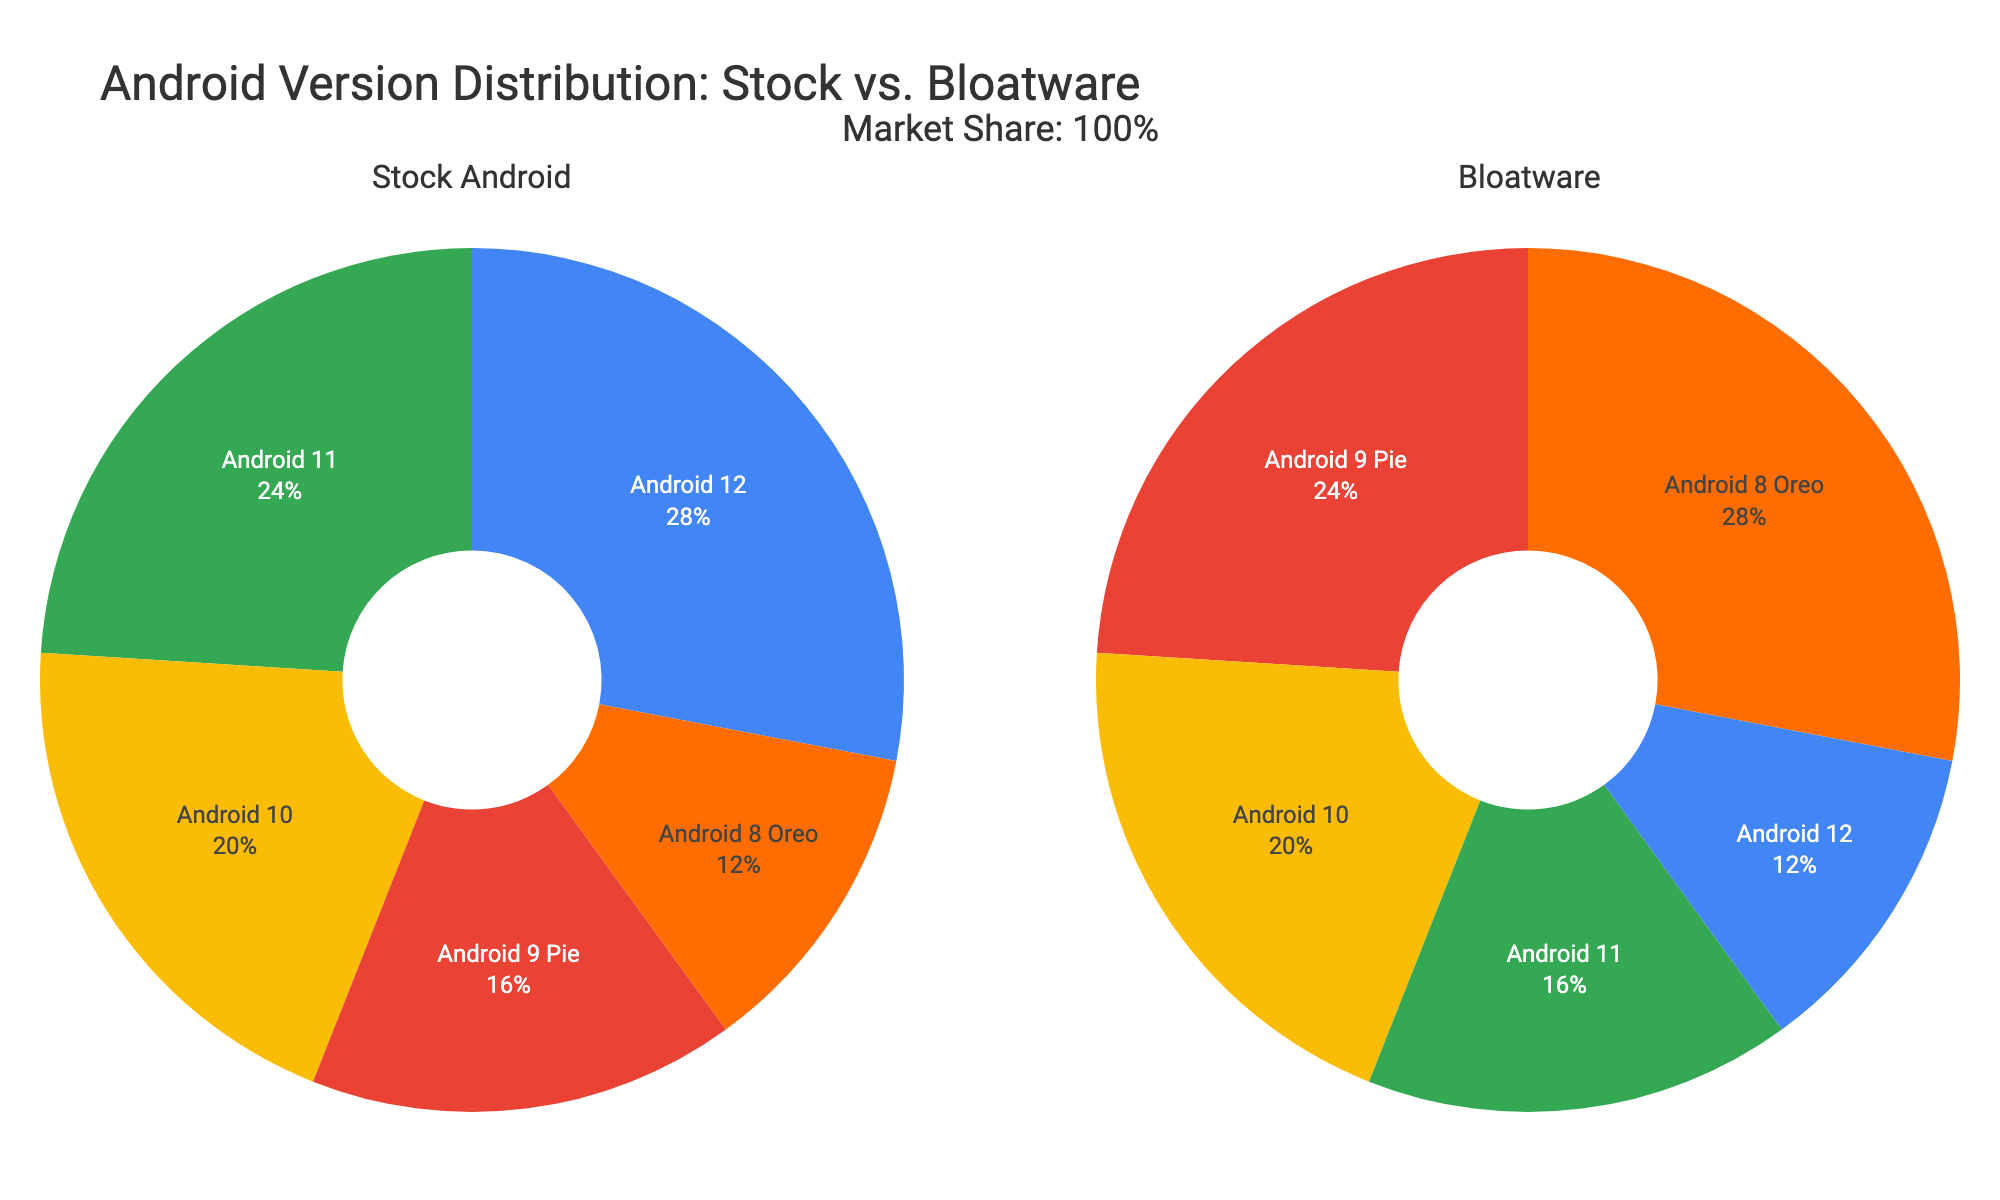What is the title of the figure? The title of the figure is located at the top and provides a summary of the data being visualized. By looking at the top of the figure, we can see the title "Android Version Distribution: Stock vs. Bloatware".
Answer: Android Version Distribution: Stock vs. Bloatware Which Android version has the highest percentage in stock Android? Each section of the stock Android pie chart is labeled with an Android version and its respective percentage. By examining these labels, we see that Android 12 has the highest percentage in stock Android.
Answer: Android 12 What is the total percentage of market share in the figure? The annotations below the subtitle mentioned, "Market Share: 100%", indicating that the total market share covered by all Android versions is 100%.
Answer: 100% Which Android version has a higher percentage of bloatware compared to stock Android? By comparing the percentages of each Android version in the "Stock Android" and "Bloatware" pie charts, we can see that Android 8 Oreo has a higher percentage in bloatware (70%) than in stock Android (30%).
Answer: Android 8 Oreo How many Android versions are depicted in the pie charts? By counting the distinct labels in each pie chart, we see that there are five Android versions: Android 12, Android 11, Android 10, Android 9 Pie, and Android 8 Oreo.
Answer: 5 Which Android version has the closest proportion between stock Android and bloatware? By observing the proportions of stock Android and bloatware for each version, Android 10 has an equal percentage of 50% for both stock Android and bloatware.
Answer: Android 10 What percentage of Android 11 users prefer stock Android? The percentage of stock Android users for each version is shown in the "Stock Android" pie chart. For Android 11, the percentage is 60%.
Answer: 60% What is the combined percentage of Android 11 and Android 12 users who prefer stock Android? Summing the percentages of stock Android for Android 11 (60%) and Android 12 (70%) yields 130%.
Answer: 130% Which chart displays the breakdown of users who have bloatware on their smartphones? The left chart is for stock Android, and the right chart is for bloatware, as indicated by the titles above each chart.
Answer: The right chart How much higher is the percentage of bloatware users for Android 9 Pie compared to the percentage of stock Android users for the same version? The respective percentages for Android 9 Pie are 40% for stock Android and 60% for bloatware. The difference is 60% - 40% = 20%.
Answer: 20% 